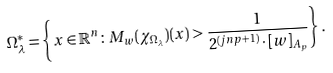<formula> <loc_0><loc_0><loc_500><loc_500>\Omega ^ { * } _ { \lambda } = \left \{ x \in \mathbb { R } ^ { n } \colon M _ { w } ( \chi _ { \Omega _ { \lambda } } ) ( x ) > \frac { 1 } { 2 ^ { ( j n p + 1 ) } \cdot [ w ] _ { A _ { p } } } \right \} .</formula> 